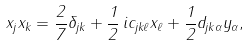Convert formula to latex. <formula><loc_0><loc_0><loc_500><loc_500>x _ { j } x _ { k } = \frac { 2 } { 7 } \delta _ { j k } + \frac { 1 } { 2 } \, i c _ { j k \ell } x _ { \ell } + \frac { 1 } { 2 } d _ { j k \alpha } y _ { \alpha } ,</formula> 